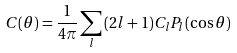<formula> <loc_0><loc_0><loc_500><loc_500>C ( \theta ) = \frac { 1 } { 4 \pi } \sum _ { l } \, ( 2 l + 1 ) C _ { l } P _ { l } ( \cos \theta )</formula> 